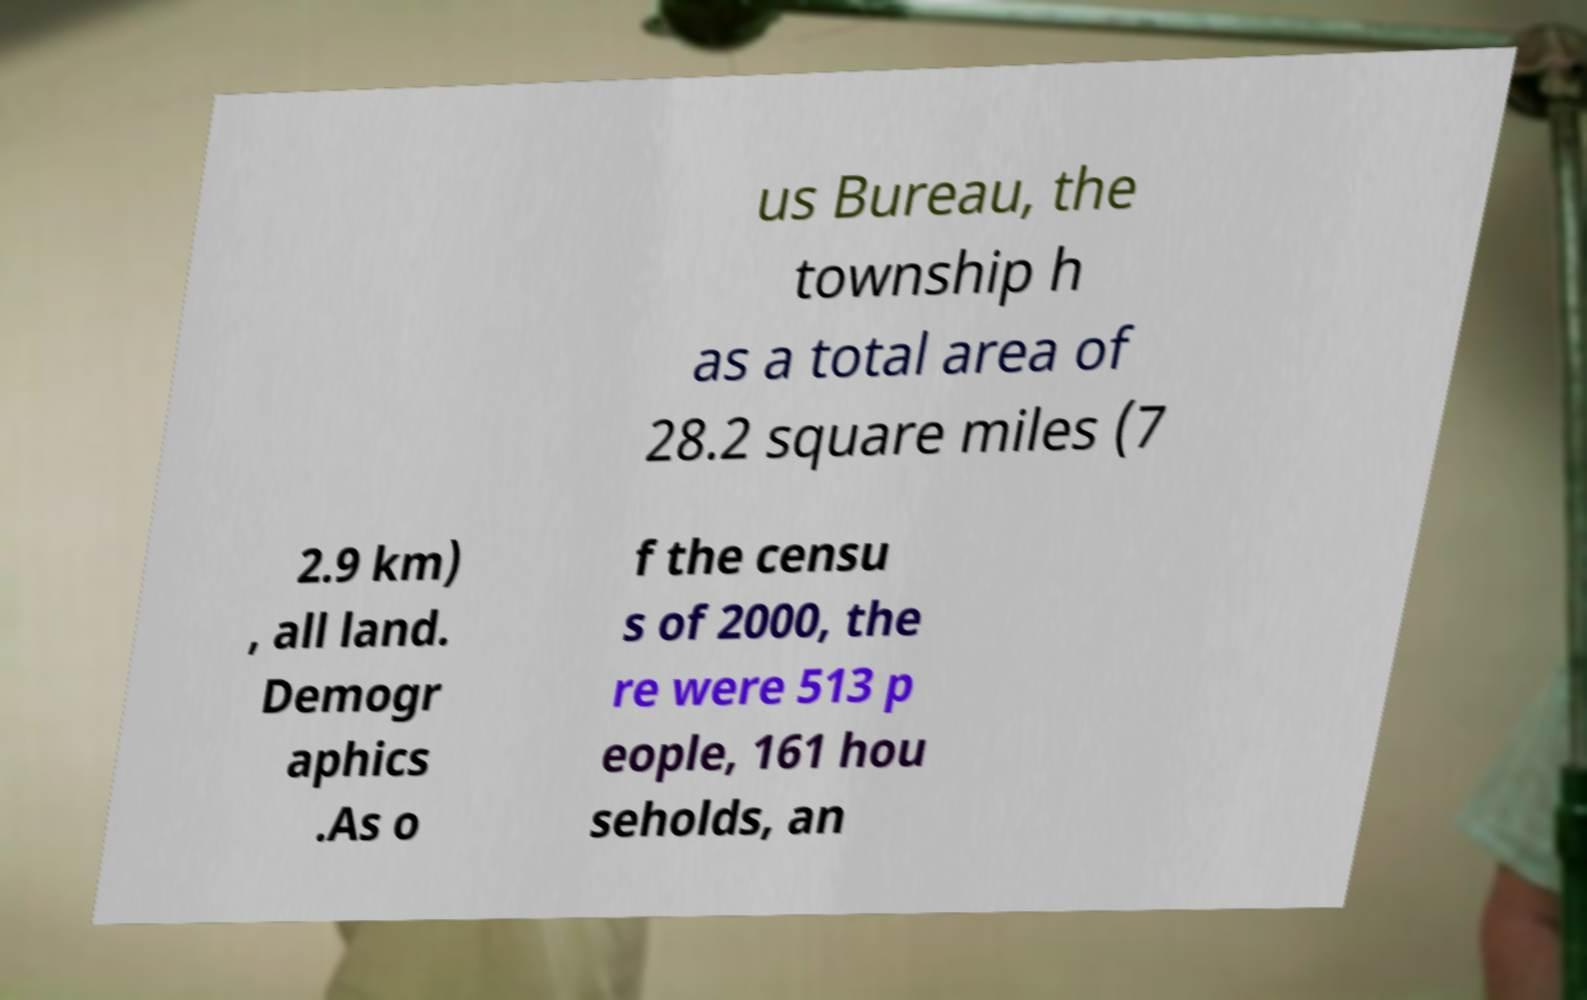Could you assist in decoding the text presented in this image and type it out clearly? us Bureau, the township h as a total area of 28.2 square miles (7 2.9 km) , all land. Demogr aphics .As o f the censu s of 2000, the re were 513 p eople, 161 hou seholds, an 